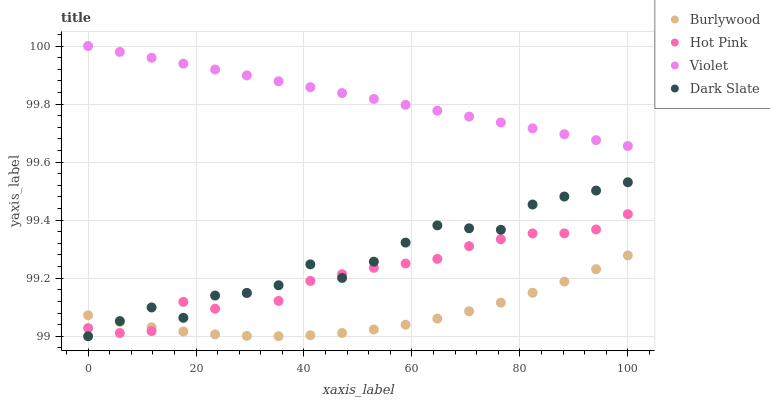Does Burlywood have the minimum area under the curve?
Answer yes or no. Yes. Does Violet have the maximum area under the curve?
Answer yes or no. Yes. Does Dark Slate have the minimum area under the curve?
Answer yes or no. No. Does Dark Slate have the maximum area under the curve?
Answer yes or no. No. Is Violet the smoothest?
Answer yes or no. Yes. Is Dark Slate the roughest?
Answer yes or no. Yes. Is Hot Pink the smoothest?
Answer yes or no. No. Is Hot Pink the roughest?
Answer yes or no. No. Does Dark Slate have the lowest value?
Answer yes or no. Yes. Does Hot Pink have the lowest value?
Answer yes or no. No. Does Violet have the highest value?
Answer yes or no. Yes. Does Dark Slate have the highest value?
Answer yes or no. No. Is Dark Slate less than Violet?
Answer yes or no. Yes. Is Violet greater than Burlywood?
Answer yes or no. Yes. Does Dark Slate intersect Hot Pink?
Answer yes or no. Yes. Is Dark Slate less than Hot Pink?
Answer yes or no. No. Is Dark Slate greater than Hot Pink?
Answer yes or no. No. Does Dark Slate intersect Violet?
Answer yes or no. No. 